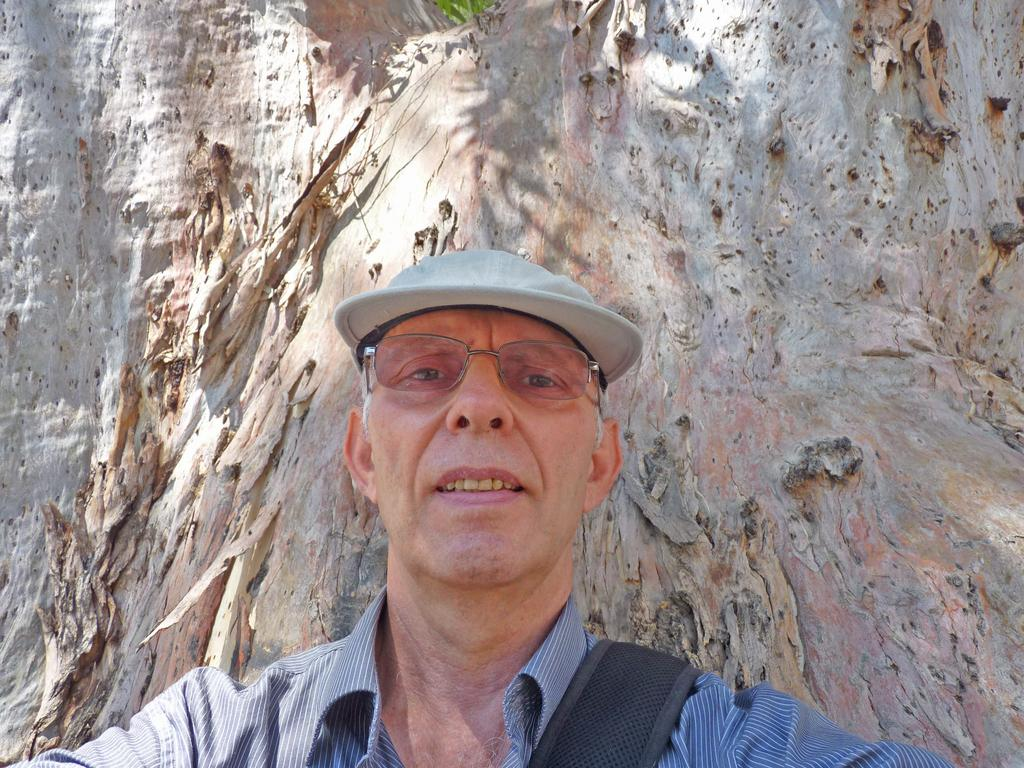What is present in the image? There is a person and a branch of a huge tree visible in the image. Can you describe the position of the branch in relation to the person? The branch of the huge tree is behind the person. How many bikes are parked under the branch in the image? There are no bikes present in the image. What type of seed can be seen falling from the branch in the image? There is no seed falling from the branch in the image. 